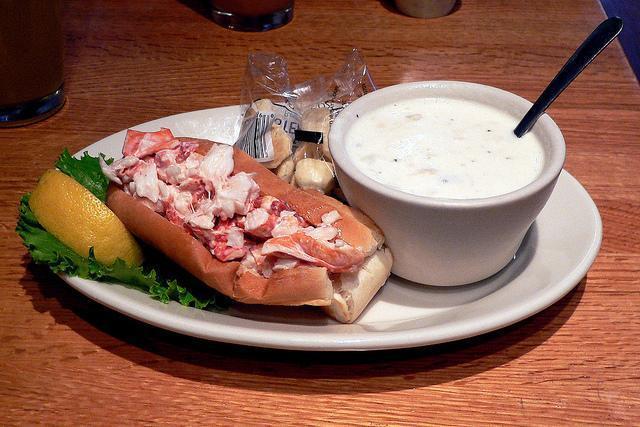Verify the accuracy of this image caption: "The orange is touching the dining table.".
Answer yes or no. No. 